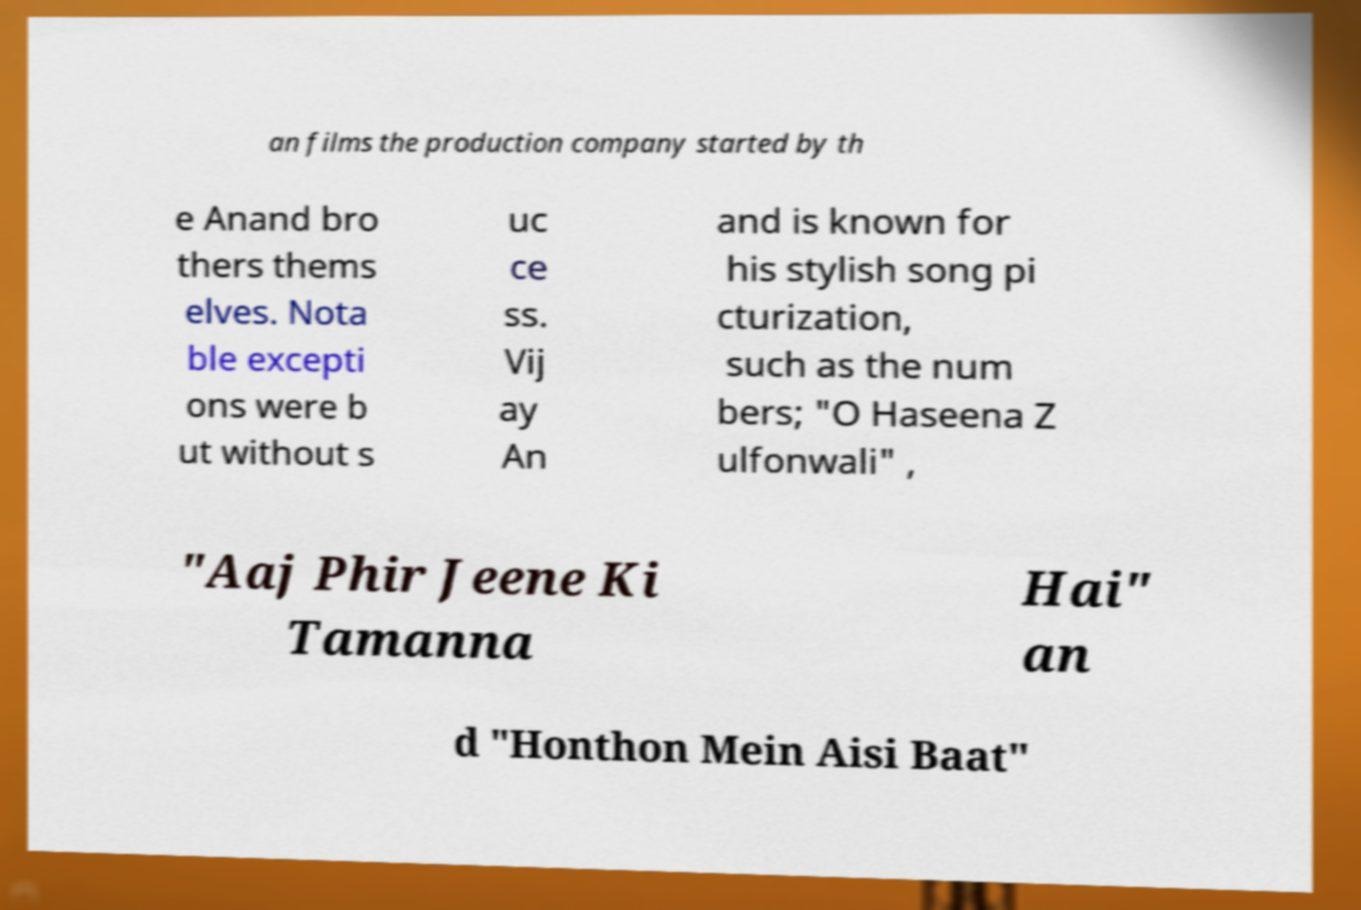Could you assist in decoding the text presented in this image and type it out clearly? an films the production company started by th e Anand bro thers thems elves. Nota ble excepti ons were b ut without s uc ce ss. Vij ay An and is known for his stylish song pi cturization, such as the num bers; "O Haseena Z ulfonwali" , "Aaj Phir Jeene Ki Tamanna Hai" an d "Honthon Mein Aisi Baat" 